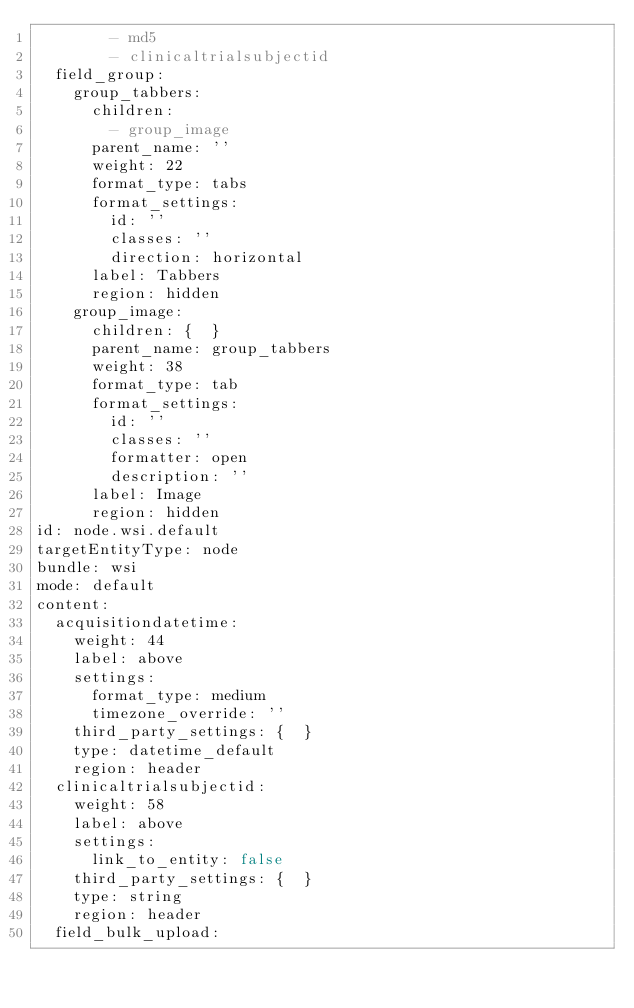<code> <loc_0><loc_0><loc_500><loc_500><_YAML_>        - md5
        - clinicaltrialsubjectid
  field_group:
    group_tabbers:
      children:
        - group_image
      parent_name: ''
      weight: 22
      format_type: tabs
      format_settings:
        id: ''
        classes: ''
        direction: horizontal
      label: Tabbers
      region: hidden
    group_image:
      children: {  }
      parent_name: group_tabbers
      weight: 38
      format_type: tab
      format_settings:
        id: ''
        classes: ''
        formatter: open
        description: ''
      label: Image
      region: hidden
id: node.wsi.default
targetEntityType: node
bundle: wsi
mode: default
content:
  acquisitiondatetime:
    weight: 44
    label: above
    settings:
      format_type: medium
      timezone_override: ''
    third_party_settings: {  }
    type: datetime_default
    region: header
  clinicaltrialsubjectid:
    weight: 58
    label: above
    settings:
      link_to_entity: false
    third_party_settings: {  }
    type: string
    region: header
  field_bulk_upload:</code> 